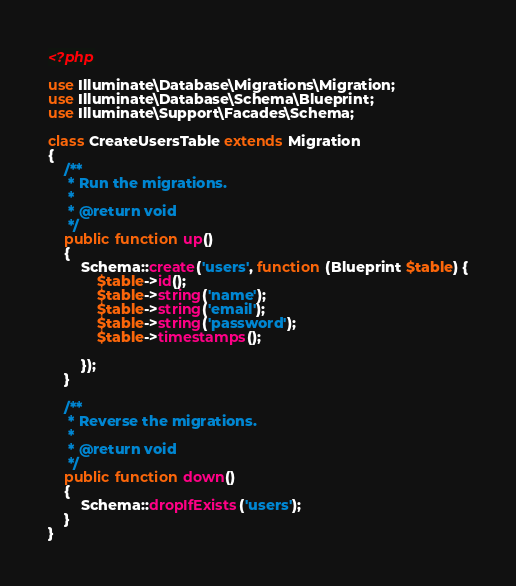<code> <loc_0><loc_0><loc_500><loc_500><_PHP_><?php

use Illuminate\Database\Migrations\Migration;
use Illuminate\Database\Schema\Blueprint;
use Illuminate\Support\Facades\Schema;

class CreateUsersTable extends Migration
{
    /**
     * Run the migrations.
     *
     * @return void
     */
    public function up()
    {
        Schema::create('users', function (Blueprint $table) {
            $table->id();
            $table->string('name');
            $table->string('email');
            $table->string('password');
            $table->timestamps();

        });
    }

    /**
     * Reverse the migrations.
     *
     * @return void
     */
    public function down()
    {
        Schema::dropIfExists('users');
    }
}
</code> 